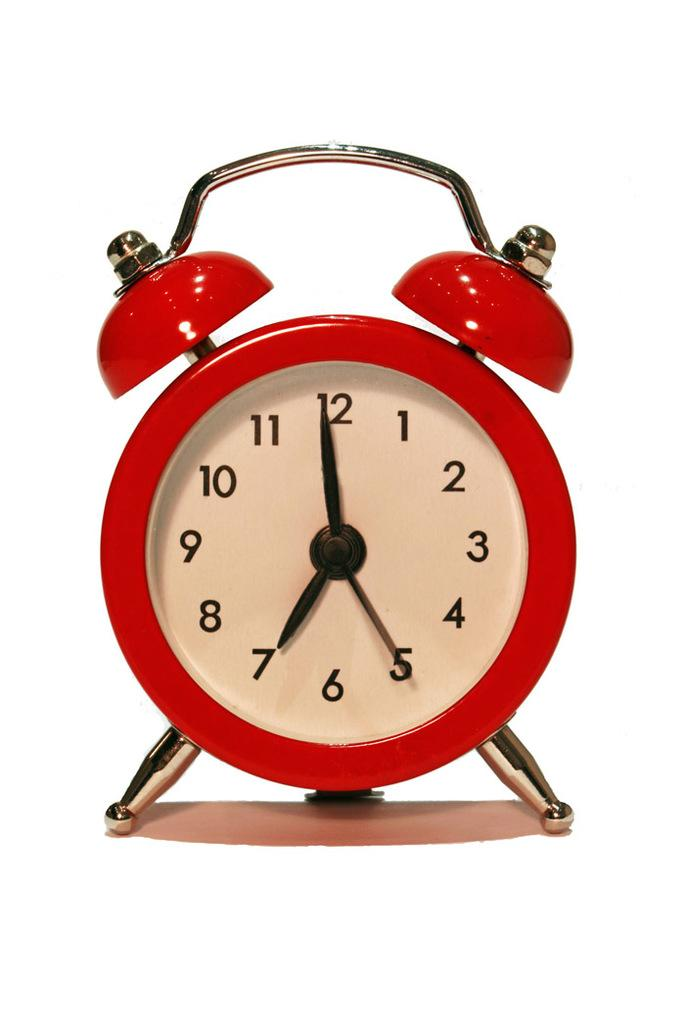Provide a one-sentence caption for the provided image. A red and white clock that signals that it is seven oclock. 